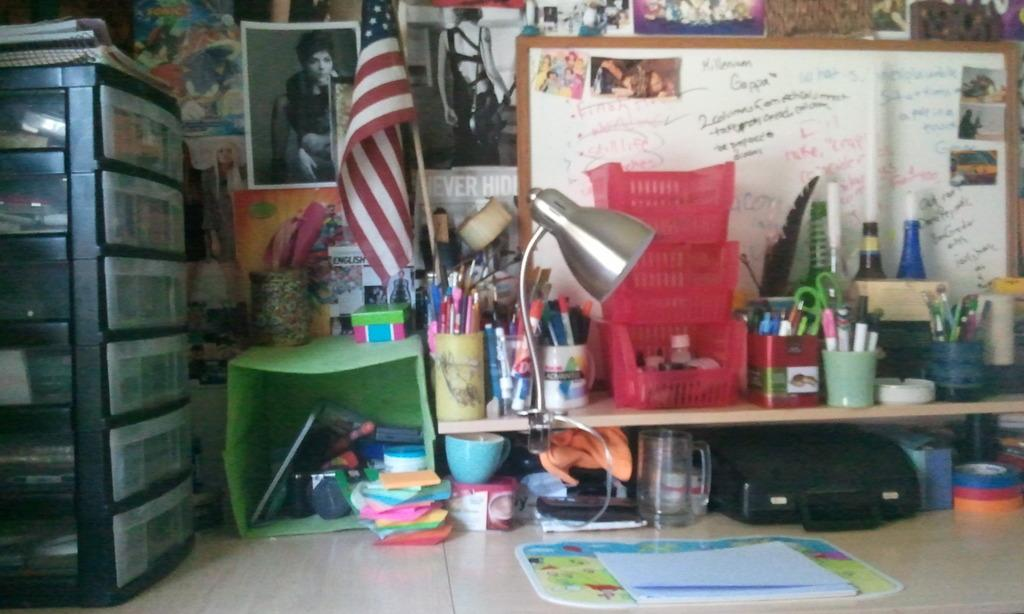<image>
Provide a brief description of the given image. A dry erase board with the word Gappa written in black. 